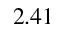<formula> <loc_0><loc_0><loc_500><loc_500>2 . 4 1</formula> 